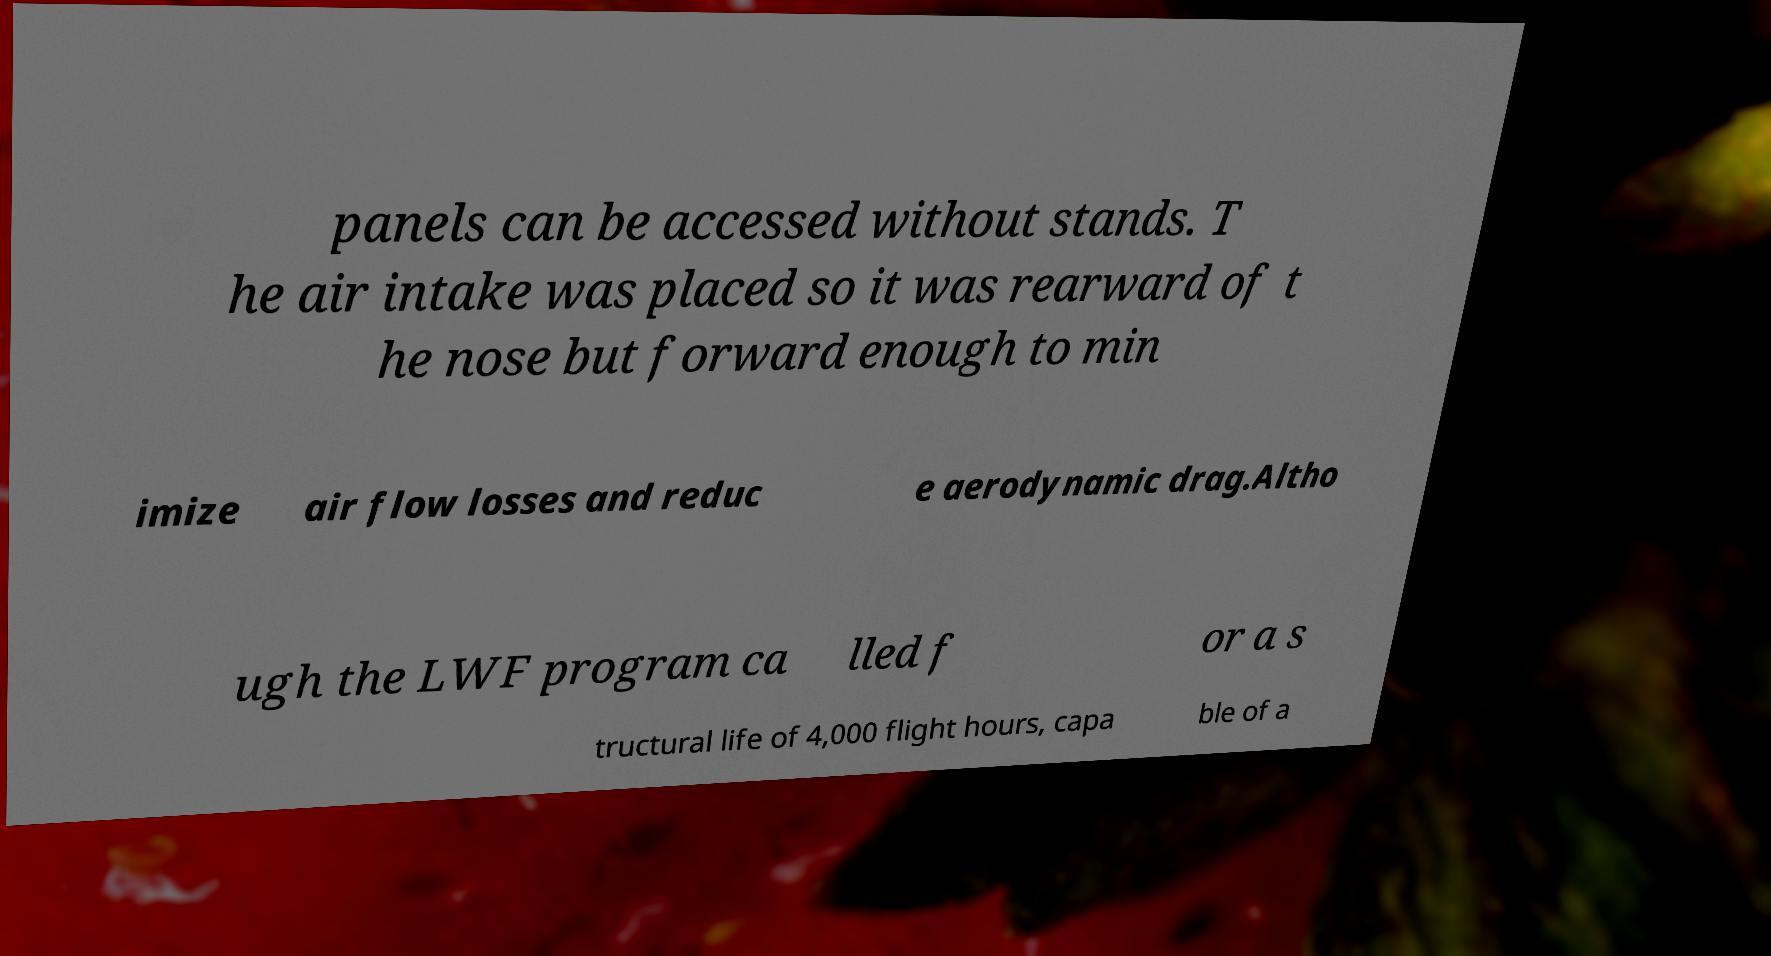Could you assist in decoding the text presented in this image and type it out clearly? panels can be accessed without stands. T he air intake was placed so it was rearward of t he nose but forward enough to min imize air flow losses and reduc e aerodynamic drag.Altho ugh the LWF program ca lled f or a s tructural life of 4,000 flight hours, capa ble of a 